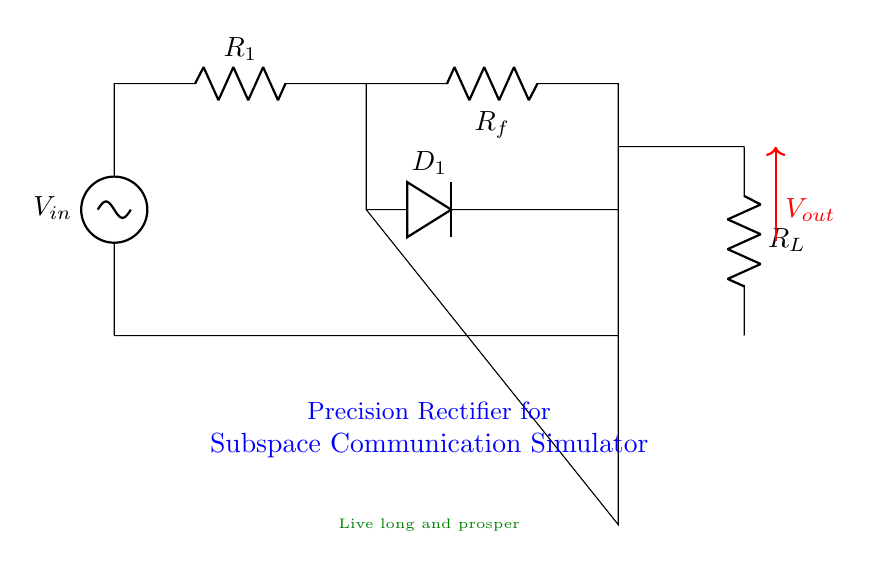What is the input voltage in this circuit? The input voltage is indicated by the symbol V_{in} at the source. Since no specific value is mentioned, it is represented as a variable.
Answer: V_{in} What components does the circuit include? The circuit consists of a voltage source, resistors, an operational amplifier, a diode, and a load resistor. Each of these components can be identified by their symbols in the diagram.
Answer: Voltage source, resistors, op amp, diode, load resistor What is the purpose of the diode in this circuit? The diode, labeled as D_1, allows current to flow in one direction, enabling the precision rectification of the input signal. This ensures that the output waveform accurately represents the positive half-cycles of the input waveform.
Answer: Precision rectification What is the role of the operational amplifier? The operational amplifier, arranged upside down in the diagram, amplifies the input signal and helps in achieving high precision in measuring small signals indicative of communication interactions.
Answer: Amplification How does the output voltage relate to the input voltage? The output voltage, labeled as V_{out}, is derived from V_{in} with the modifications introduced by the op amp and diode. This indicates that V_{out} reflects the precise rectified value of the input voltage during its positive half-cycle.
Answer: V_{out} is rectified V_{in} What is the significance of resistor R_f in the circuit? Resistor R_f provides feedback from the output of the op amp to its inverting input, which is critical for setting the gain of the operational amplifier and helping to ensure stability in the precision rectifier operation.
Answer: Gain setting What type of rectifier is represented in this circuit? The circuit diagram represents a precision rectifier, which is designed to rectify signals with high precision, as opposed to a standard diode rectifier, which may not accurately handle small input signals.
Answer: Precision rectifier 